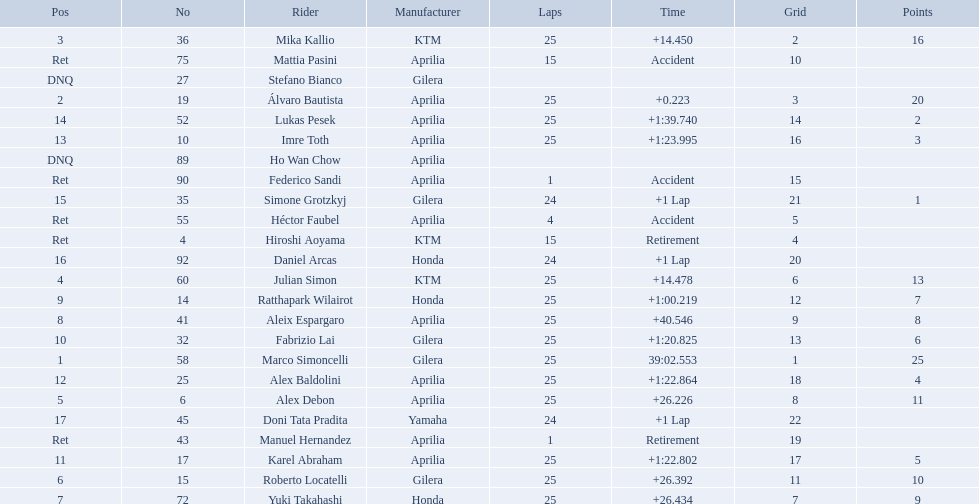How many laps did marco perform? 25. Would you mind parsing the complete table? {'header': ['Pos', 'No', 'Rider', 'Manufacturer', 'Laps', 'Time', 'Grid', 'Points'], 'rows': [['3', '36', 'Mika Kallio', 'KTM', '25', '+14.450', '2', '16'], ['Ret', '75', 'Mattia Pasini', 'Aprilia', '15', 'Accident', '10', ''], ['DNQ', '27', 'Stefano Bianco', 'Gilera', '', '', '', ''], ['2', '19', 'Álvaro Bautista', 'Aprilia', '25', '+0.223', '3', '20'], ['14', '52', 'Lukas Pesek', 'Aprilia', '25', '+1:39.740', '14', '2'], ['13', '10', 'Imre Toth', 'Aprilia', '25', '+1:23.995', '16', '3'], ['DNQ', '89', 'Ho Wan Chow', 'Aprilia', '', '', '', ''], ['Ret', '90', 'Federico Sandi', 'Aprilia', '1', 'Accident', '15', ''], ['15', '35', 'Simone Grotzkyj', 'Gilera', '24', '+1 Lap', '21', '1'], ['Ret', '55', 'Héctor Faubel', 'Aprilia', '4', 'Accident', '5', ''], ['Ret', '4', 'Hiroshi Aoyama', 'KTM', '15', 'Retirement', '4', ''], ['16', '92', 'Daniel Arcas', 'Honda', '24', '+1 Lap', '20', ''], ['4', '60', 'Julian Simon', 'KTM', '25', '+14.478', '6', '13'], ['9', '14', 'Ratthapark Wilairot', 'Honda', '25', '+1:00.219', '12', '7'], ['8', '41', 'Aleix Espargaro', 'Aprilia', '25', '+40.546', '9', '8'], ['10', '32', 'Fabrizio Lai', 'Gilera', '25', '+1:20.825', '13', '6'], ['1', '58', 'Marco Simoncelli', 'Gilera', '25', '39:02.553', '1', '25'], ['12', '25', 'Alex Baldolini', 'Aprilia', '25', '+1:22.864', '18', '4'], ['5', '6', 'Alex Debon', 'Aprilia', '25', '+26.226', '8', '11'], ['17', '45', 'Doni Tata Pradita', 'Yamaha', '24', '+1 Lap', '22', ''], ['Ret', '43', 'Manuel Hernandez', 'Aprilia', '1', 'Retirement', '19', ''], ['11', '17', 'Karel Abraham', 'Aprilia', '25', '+1:22.802', '17', '5'], ['6', '15', 'Roberto Locatelli', 'Gilera', '25', '+26.392', '11', '10'], ['7', '72', 'Yuki Takahashi', 'Honda', '25', '+26.434', '7', '9']]} How many laps did hiroshi perform? 15. Which of these numbers are higher? 25. Who swam this number of laps? Marco Simoncelli. 